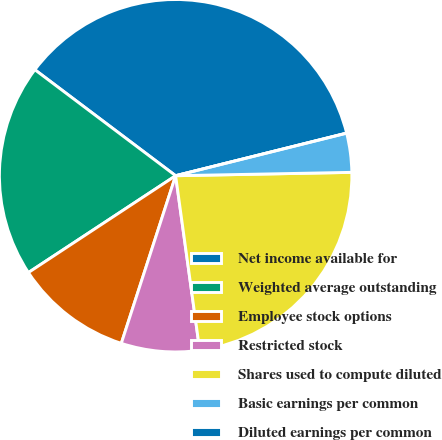<chart> <loc_0><loc_0><loc_500><loc_500><pie_chart><fcel>Net income available for<fcel>Weighted average outstanding<fcel>Employee stock options<fcel>Restricted stock<fcel>Shares used to compute diluted<fcel>Basic earnings per common<fcel>Diluted earnings per common<nl><fcel>35.84%<fcel>19.53%<fcel>10.75%<fcel>7.17%<fcel>23.12%<fcel>3.58%<fcel>0.0%<nl></chart> 